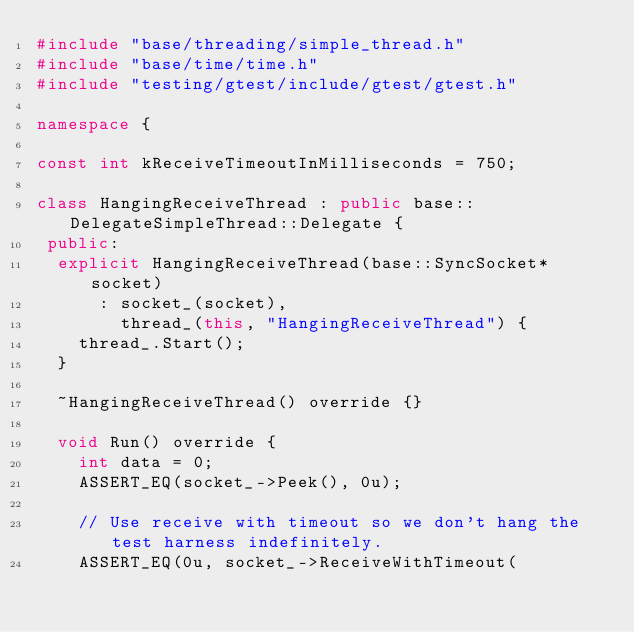<code> <loc_0><loc_0><loc_500><loc_500><_C++_>#include "base/threading/simple_thread.h"
#include "base/time/time.h"
#include "testing/gtest/include/gtest/gtest.h"

namespace {

const int kReceiveTimeoutInMilliseconds = 750;

class HangingReceiveThread : public base::DelegateSimpleThread::Delegate {
 public:
  explicit HangingReceiveThread(base::SyncSocket* socket)
      : socket_(socket),
        thread_(this, "HangingReceiveThread") {
    thread_.Start();
  }

  ~HangingReceiveThread() override {}

  void Run() override {
    int data = 0;
    ASSERT_EQ(socket_->Peek(), 0u);

    // Use receive with timeout so we don't hang the test harness indefinitely.
    ASSERT_EQ(0u, socket_->ReceiveWithTimeout(</code> 